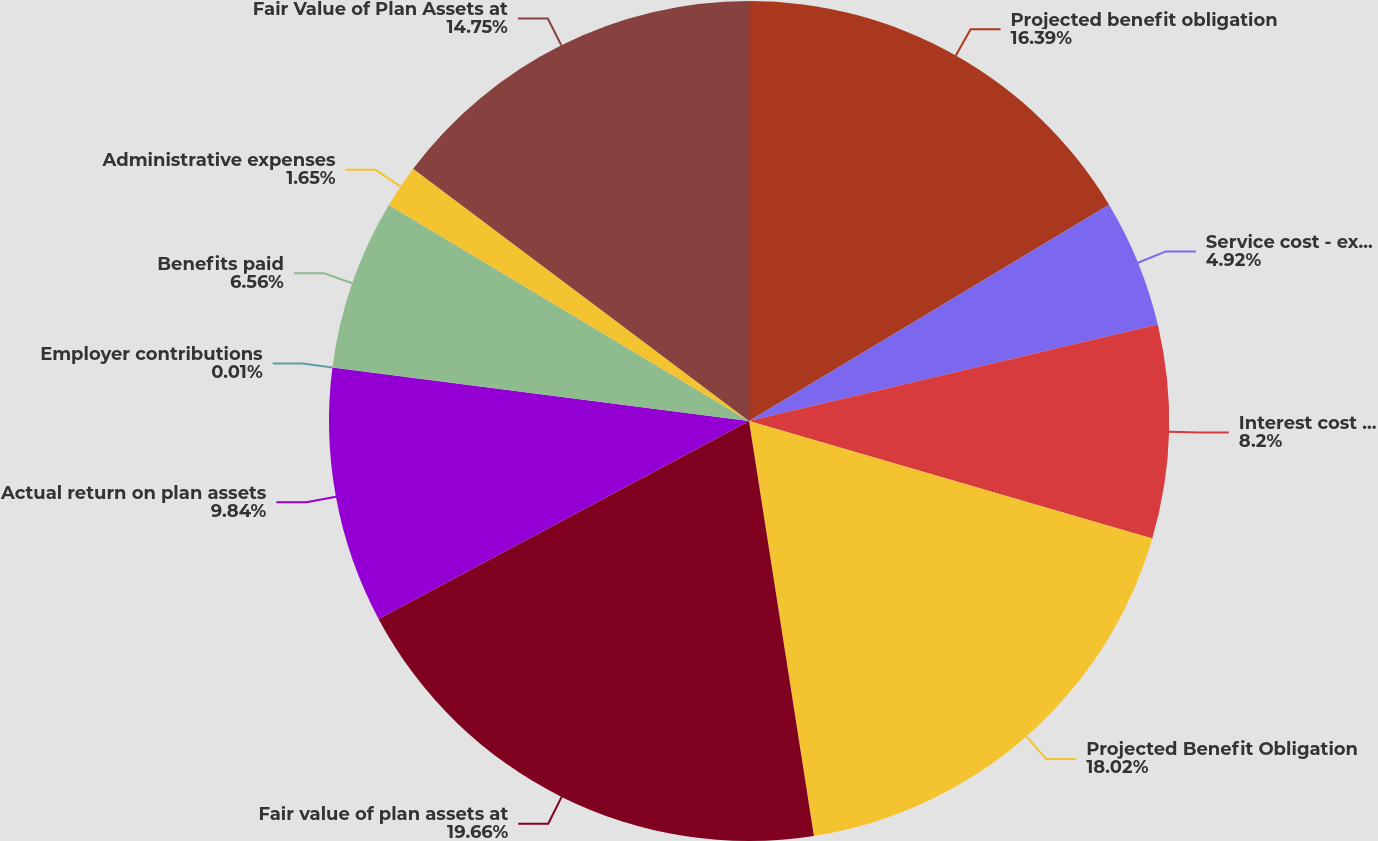Convert chart to OTSL. <chart><loc_0><loc_0><loc_500><loc_500><pie_chart><fcel>Projected benefit obligation<fcel>Service cost - excluding<fcel>Interest cost on projected<fcel>Projected Benefit Obligation<fcel>Fair value of plan assets at<fcel>Actual return on plan assets<fcel>Employer contributions<fcel>Benefits paid<fcel>Administrative expenses<fcel>Fair Value of Plan Assets at<nl><fcel>16.39%<fcel>4.92%<fcel>8.2%<fcel>18.02%<fcel>19.66%<fcel>9.84%<fcel>0.01%<fcel>6.56%<fcel>1.65%<fcel>14.75%<nl></chart> 